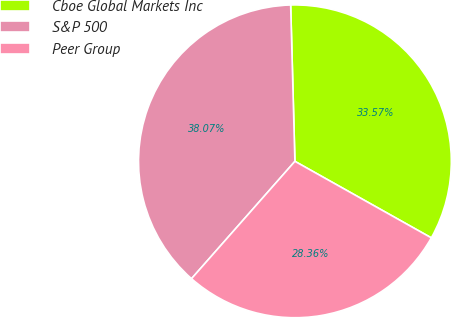Convert chart to OTSL. <chart><loc_0><loc_0><loc_500><loc_500><pie_chart><fcel>Cboe Global Markets Inc<fcel>S&P 500<fcel>Peer Group<nl><fcel>33.57%<fcel>38.07%<fcel>28.36%<nl></chart> 